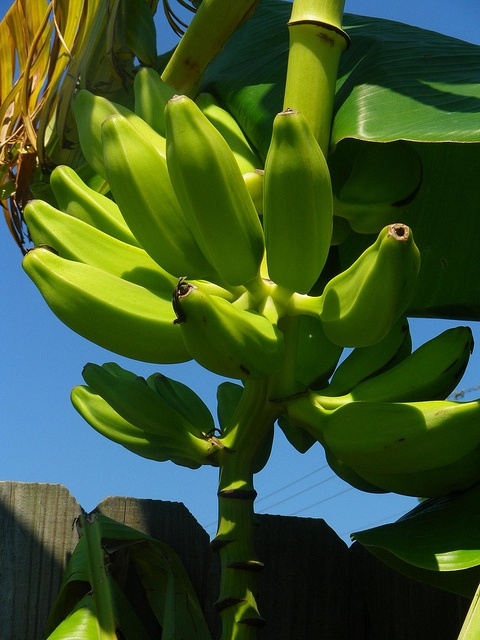Describe the objects in this image and their specific colors. I can see banana in blue, darkgreen, khaki, and yellow tones, banana in blue, darkgreen, lightblue, and yellow tones, banana in blue, darkgreen, and olive tones, banana in blue, darkgreen, and olive tones, and banana in blue, darkgreen, and olive tones in this image. 